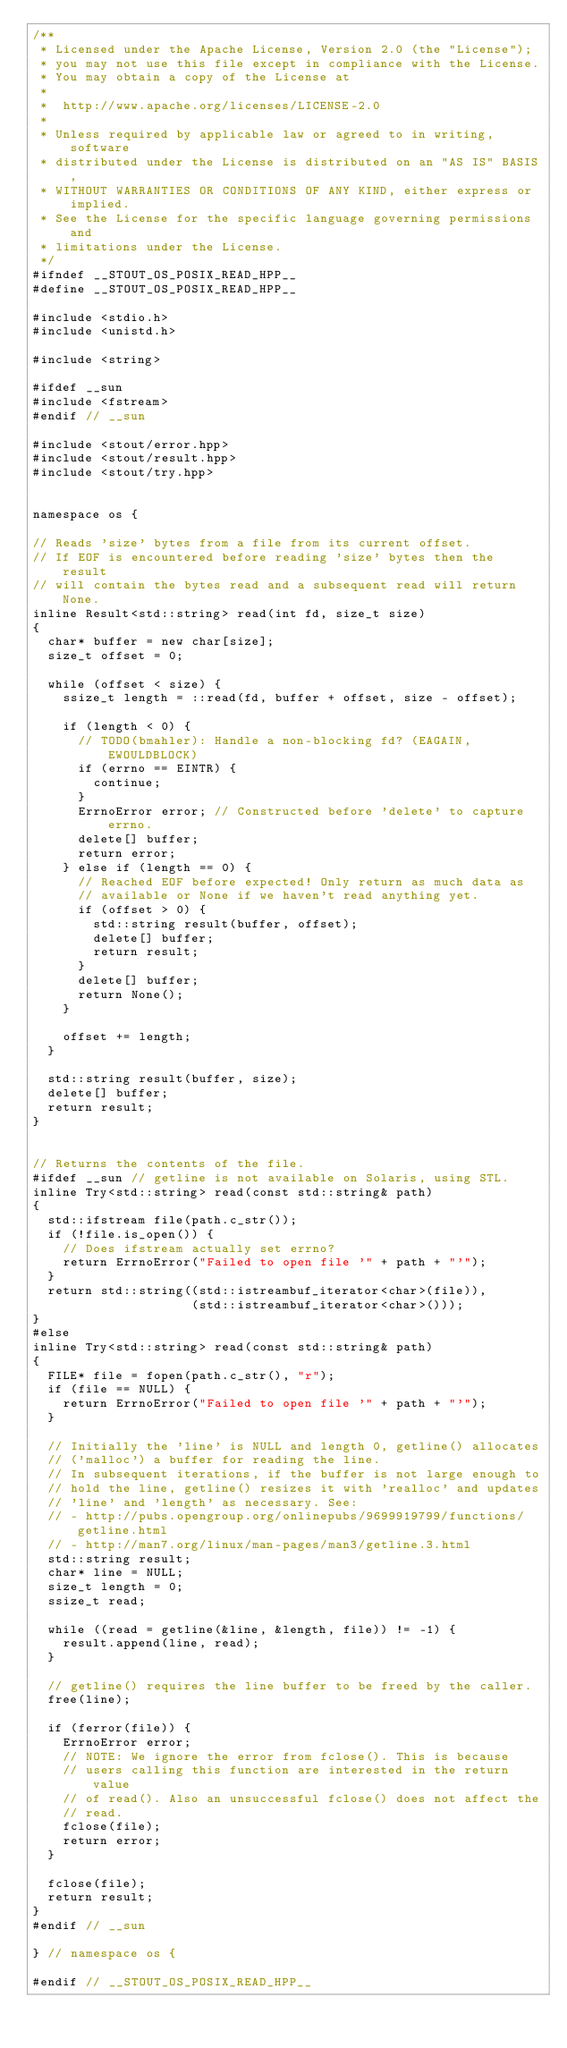<code> <loc_0><loc_0><loc_500><loc_500><_C++_>/**
 * Licensed under the Apache License, Version 2.0 (the "License");
 * you may not use this file except in compliance with the License.
 * You may obtain a copy of the License at
 *
 *  http://www.apache.org/licenses/LICENSE-2.0
 *
 * Unless required by applicable law or agreed to in writing, software
 * distributed under the License is distributed on an "AS IS" BASIS,
 * WITHOUT WARRANTIES OR CONDITIONS OF ANY KIND, either express or implied.
 * See the License for the specific language governing permissions and
 * limitations under the License.
 */
#ifndef __STOUT_OS_POSIX_READ_HPP__
#define __STOUT_OS_POSIX_READ_HPP__

#include <stdio.h>
#include <unistd.h>

#include <string>

#ifdef __sun
#include <fstream>
#endif // __sun

#include <stout/error.hpp>
#include <stout/result.hpp>
#include <stout/try.hpp>


namespace os {

// Reads 'size' bytes from a file from its current offset.
// If EOF is encountered before reading 'size' bytes then the result
// will contain the bytes read and a subsequent read will return None.
inline Result<std::string> read(int fd, size_t size)
{
  char* buffer = new char[size];
  size_t offset = 0;

  while (offset < size) {
    ssize_t length = ::read(fd, buffer + offset, size - offset);

    if (length < 0) {
      // TODO(bmahler): Handle a non-blocking fd? (EAGAIN, EWOULDBLOCK)
      if (errno == EINTR) {
        continue;
      }
      ErrnoError error; // Constructed before 'delete' to capture errno.
      delete[] buffer;
      return error;
    } else if (length == 0) {
      // Reached EOF before expected! Only return as much data as
      // available or None if we haven't read anything yet.
      if (offset > 0) {
        std::string result(buffer, offset);
        delete[] buffer;
        return result;
      }
      delete[] buffer;
      return None();
    }

    offset += length;
  }

  std::string result(buffer, size);
  delete[] buffer;
  return result;
}


// Returns the contents of the file.
#ifdef __sun // getline is not available on Solaris, using STL.
inline Try<std::string> read(const std::string& path)
{
  std::ifstream file(path.c_str());
  if (!file.is_open()) {
    // Does ifstream actually set errno?
    return ErrnoError("Failed to open file '" + path + "'");
  }
  return std::string((std::istreambuf_iterator<char>(file)),
                     (std::istreambuf_iterator<char>()));
}
#else
inline Try<std::string> read(const std::string& path)
{
  FILE* file = fopen(path.c_str(), "r");
  if (file == NULL) {
    return ErrnoError("Failed to open file '" + path + "'");
  }

  // Initially the 'line' is NULL and length 0, getline() allocates
  // ('malloc') a buffer for reading the line.
  // In subsequent iterations, if the buffer is not large enough to
  // hold the line, getline() resizes it with 'realloc' and updates
  // 'line' and 'length' as necessary. See:
  // - http://pubs.opengroup.org/onlinepubs/9699919799/functions/getline.html
  // - http://man7.org/linux/man-pages/man3/getline.3.html
  std::string result;
  char* line = NULL;
  size_t length = 0;
  ssize_t read;

  while ((read = getline(&line, &length, file)) != -1) {
    result.append(line, read);
  }

  // getline() requires the line buffer to be freed by the caller.
  free(line);

  if (ferror(file)) {
    ErrnoError error;
    // NOTE: We ignore the error from fclose(). This is because
    // users calling this function are interested in the return value
    // of read(). Also an unsuccessful fclose() does not affect the
    // read.
    fclose(file);
    return error;
  }

  fclose(file);
  return result;
}
#endif // __sun

} // namespace os {

#endif // __STOUT_OS_POSIX_READ_HPP__
</code> 